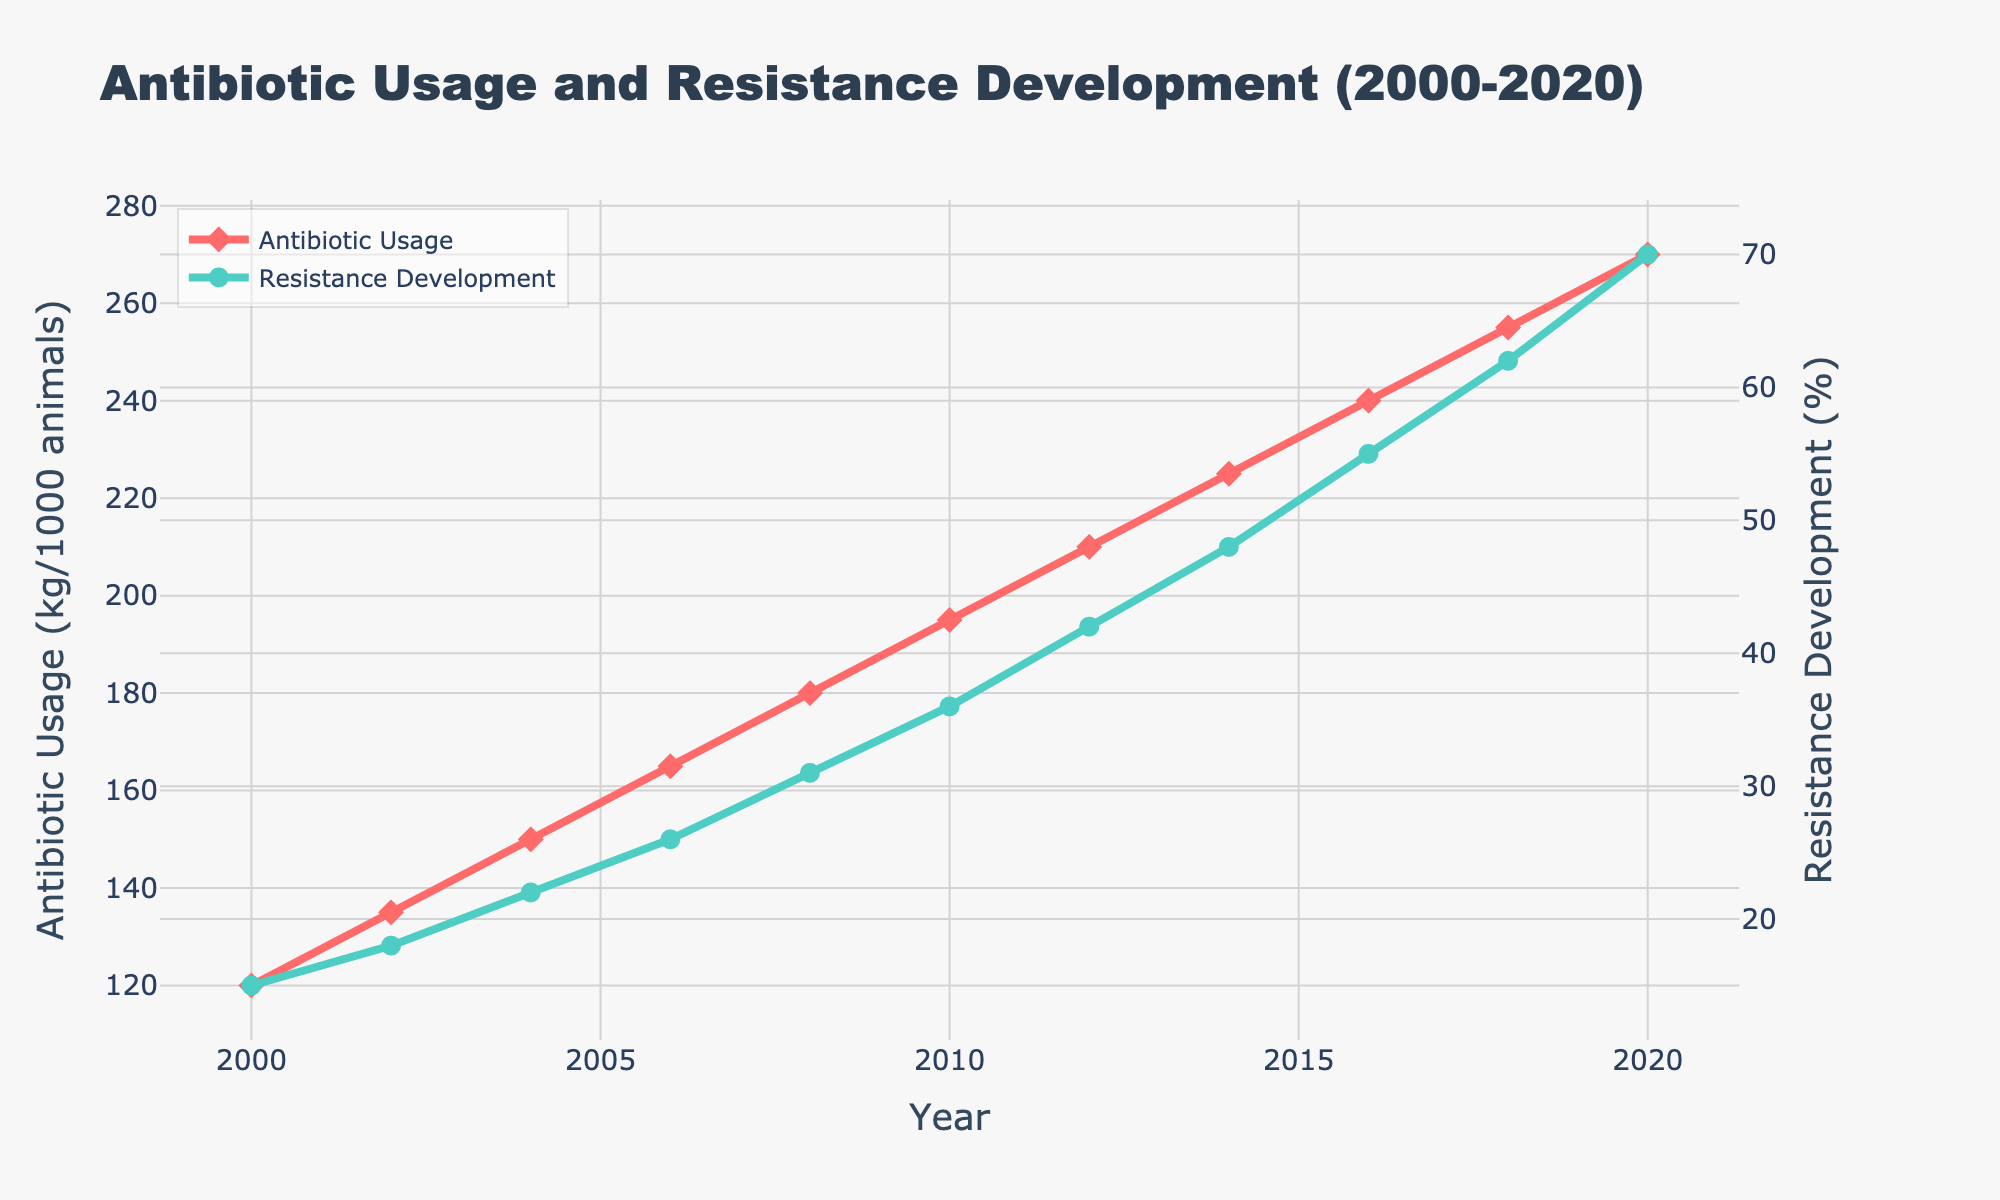What trend do you see in antibiotic usage from 2000 to 2020? The line for antibiotic usage (red line) shows a continuous upward trend from 2000 to 2020.
Answer: Continuous increase From which year did resistance development exceed 50%? By observing the green line for resistance development, it can be seen that it exceeded 50% in the year 2016.
Answer: 2016 How does the increase in antibiotic usage from 2000 to 2010 compare to the increase from 2010 to 2020? Antibiotic usage increased from 120 kg/1000 animals in 2000 to 195 kg/1000 animals in 2010 (an increase of 75 kg). From 2010 to 2020, it increased from 195 kg to 270 kg (an increase of 75 kg). Both periods saw an equal increase of 75 kg.
Answer: Equal increase What is the percentage increase in resistance development from 2000 to 2020? Resistance development increased from 15% in 2000 to 70% in 2020. The percentage increase is calculated as ((70 - 15) / 15) * 100 = 366.67%.
Answer: 366.67% Which year saw the highest antibiotic usage? By looking at the peak of the red line, it is clear that 2020 saw the highest antibiotic usage.
Answer: 2020 What was the difference in resistance development between 2010 and 2018? Resistance development in 2010 was 36%, and in 2018 it was 62%. The difference is 62% - 36% = 26%.
Answer: 26% What visual elements distinguish antibiotic usage from resistance development in the chart? Antibiotic usage is represented by a red line with diamond markers, while resistance development is represented by a green line with circle markers.
Answer: Colors and markers How much did antibiotic usage increase per year on average from 2000 to 2020? Over 20 years, antibiotic usage increased from 120 to 270 kg/1000 animals, an increase of 150 kg. The average increase per year is 150 kg/20 years = 7.5 kg/year.
Answer: 7.5 kg/year Compare the resistance development in 2008 to 2014. Which year had higher values and by how much? Resistance development was 31% in 2008 and 48% in 2014. 48% - 31% = 17%, hence 2014 had a higher value by 17%.
Answer: 2014 by 17% 